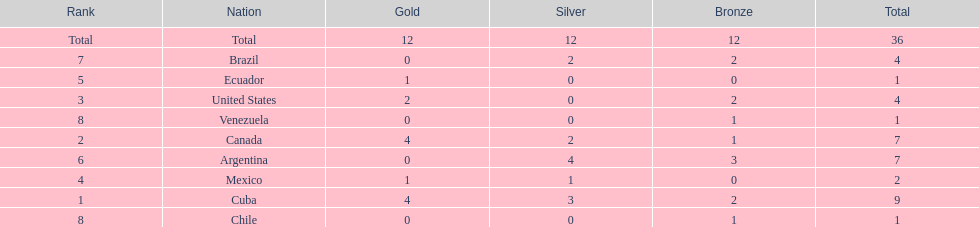Would you be able to parse every entry in this table? {'header': ['Rank', 'Nation', 'Gold', 'Silver', 'Bronze', 'Total'], 'rows': [['Total', 'Total', '12', '12', '12', '36'], ['7', 'Brazil', '0', '2', '2', '4'], ['5', 'Ecuador', '1', '0', '0', '1'], ['3', 'United States', '2', '0', '2', '4'], ['8', 'Venezuela', '0', '0', '1', '1'], ['2', 'Canada', '4', '2', '1', '7'], ['6', 'Argentina', '0', '4', '3', '7'], ['4', 'Mexico', '1', '1', '0', '2'], ['1', 'Cuba', '4', '3', '2', '9'], ['8', 'Chile', '0', '0', '1', '1']]} Which nation won gold but did not win silver? United States. 